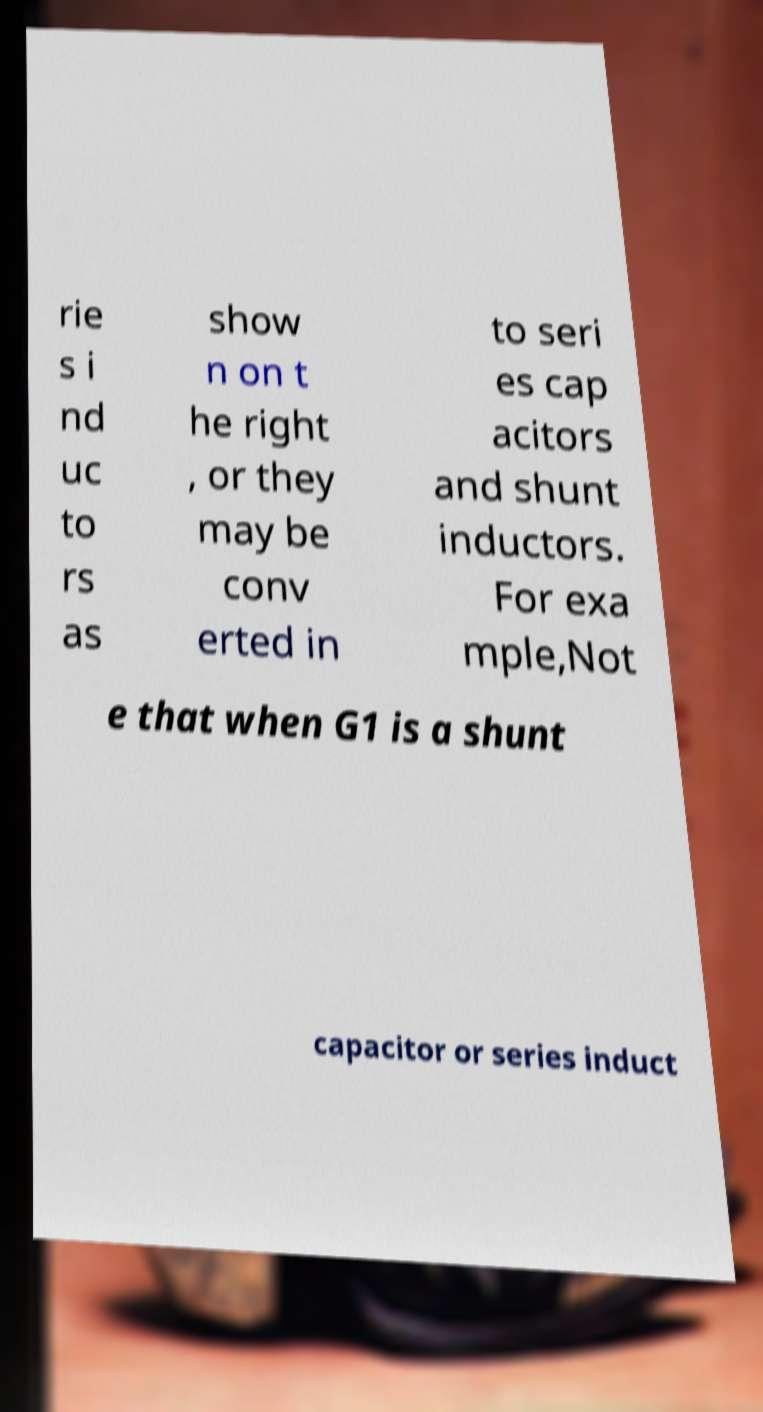Can you accurately transcribe the text from the provided image for me? rie s i nd uc to rs as show n on t he right , or they may be conv erted in to seri es cap acitors and shunt inductors. For exa mple,Not e that when G1 is a shunt capacitor or series induct 